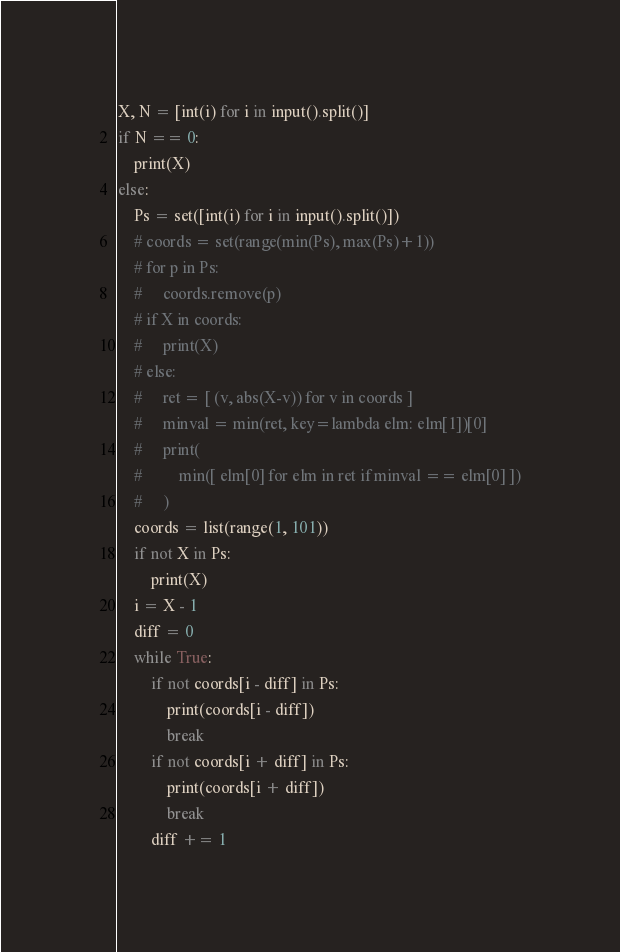Convert code to text. <code><loc_0><loc_0><loc_500><loc_500><_Python_>X, N = [int(i) for i in input().split()]
if N == 0:
    print(X)
else:
    Ps = set([int(i) for i in input().split()])
    # coords = set(range(min(Ps), max(Ps)+1))
    # for p in Ps:
    #     coords.remove(p)
    # if X in coords:
    #     print(X)
    # else:
    #     ret = [ (v, abs(X-v)) for v in coords ]
    #     minval = min(ret, key=lambda elm: elm[1])[0]
    #     print(
    #         min([ elm[0] for elm in ret if minval == elm[0] ])
    #     )
    coords = list(range(1, 101))
    if not X in Ps:
        print(X)
    i = X - 1
    diff = 0
    while True:
        if not coords[i - diff] in Ps:
            print(coords[i - diff])
            break
        if not coords[i + diff] in Ps:
            print(coords[i + diff])
            break
        diff += 1</code> 